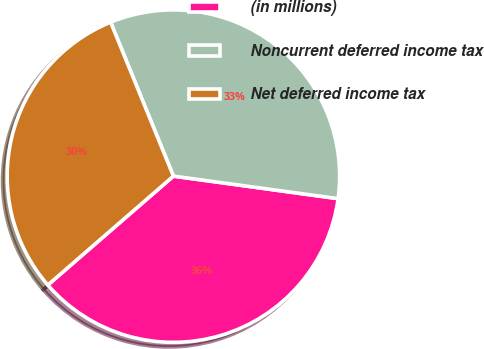<chart> <loc_0><loc_0><loc_500><loc_500><pie_chart><fcel>(in millions)<fcel>Noncurrent deferred income tax<fcel>Net deferred income tax<nl><fcel>36.46%<fcel>33.33%<fcel>30.2%<nl></chart> 